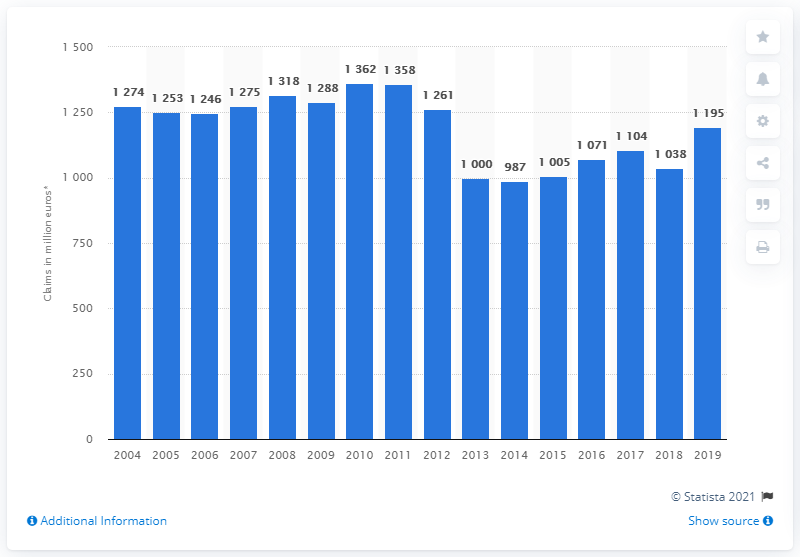Identify some key points in this picture. In 2010, the annual aggregate payments value was 1,246. 